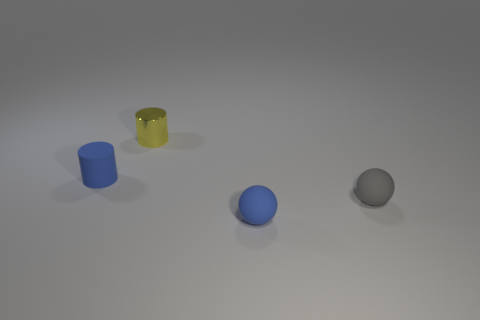What number of other things are there of the same color as the tiny metallic object?
Offer a terse response. 0. What color is the metal thing?
Your answer should be compact. Yellow. How big is the object that is both behind the tiny blue sphere and in front of the blue cylinder?
Provide a succinct answer. Small. What number of things are blue things that are left of the tiny yellow cylinder or tiny yellow rubber balls?
Your answer should be compact. 1. The tiny blue object that is made of the same material as the blue cylinder is what shape?
Offer a very short reply. Sphere. What is the shape of the tiny shiny object?
Provide a short and direct response. Cylinder. The object that is both behind the small blue sphere and right of the yellow thing is what color?
Make the answer very short. Gray. There is a blue thing that is the same size as the blue matte ball; what shape is it?
Your answer should be very brief. Cylinder. Are there any blue things that have the same shape as the tiny gray rubber object?
Provide a short and direct response. Yes. Does the small gray sphere have the same material as the small blue object behind the small blue rubber sphere?
Provide a short and direct response. Yes. 